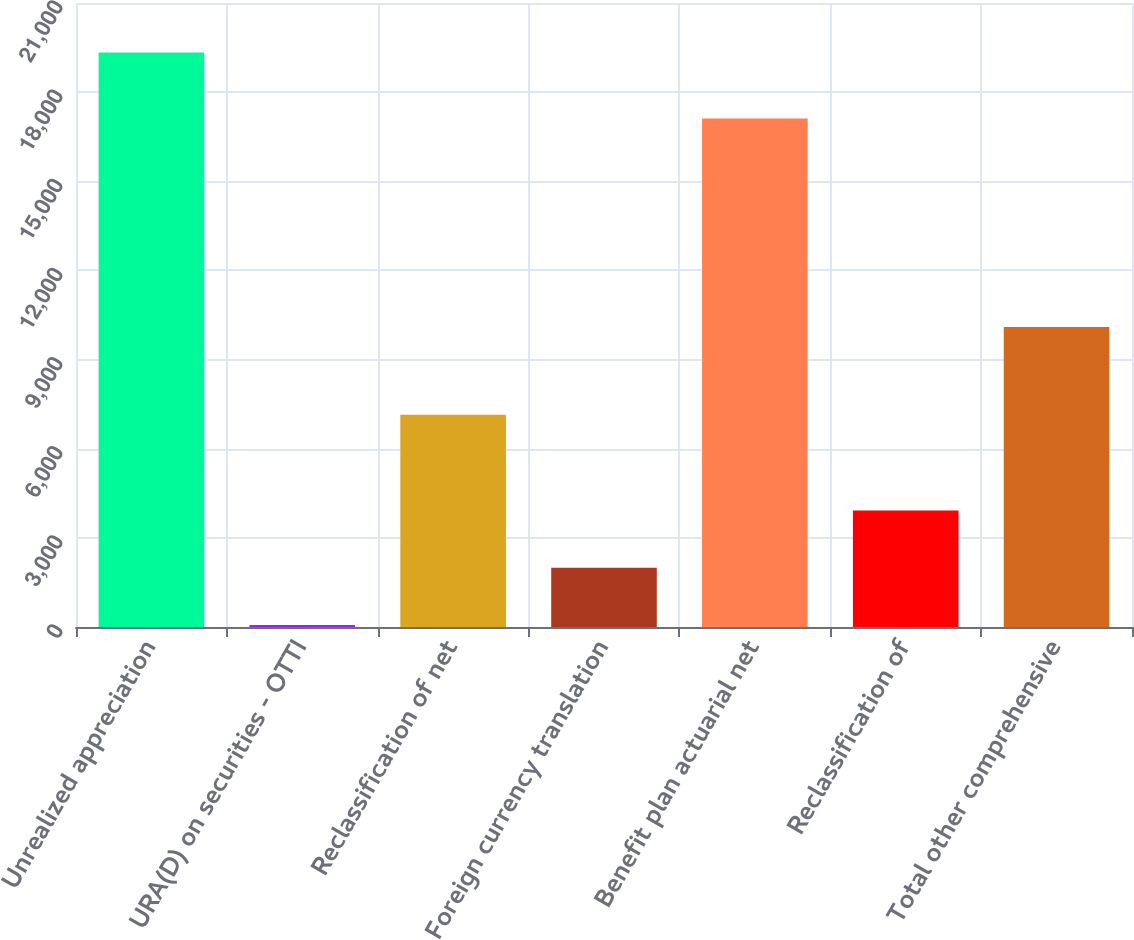Convert chart. <chart><loc_0><loc_0><loc_500><loc_500><bar_chart><fcel>Unrealized appreciation<fcel>URA(D) on securities - OTTI<fcel>Reclassification of net<fcel>Foreign currency translation<fcel>Benefit plan actuarial net<fcel>Reclassification of<fcel>Total other comprehensive<nl><fcel>19338<fcel>66<fcel>7146<fcel>1993.2<fcel>17109<fcel>3920.4<fcel>10100<nl></chart> 